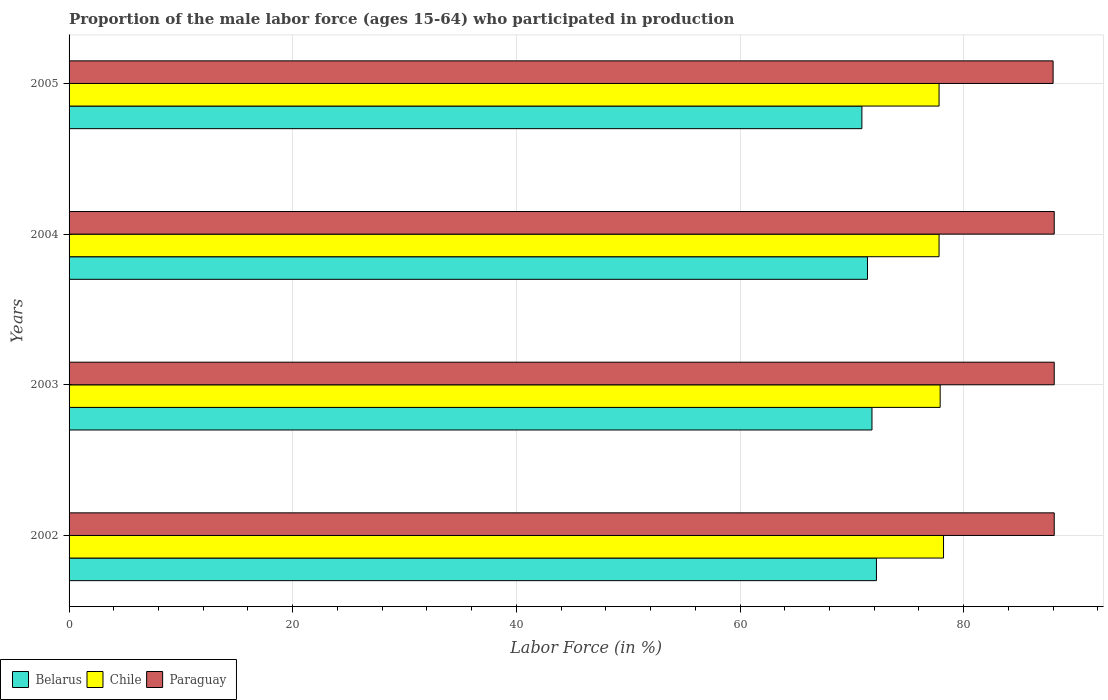How many different coloured bars are there?
Ensure brevity in your answer.  3. Are the number of bars per tick equal to the number of legend labels?
Your answer should be compact. Yes. How many bars are there on the 4th tick from the bottom?
Offer a terse response. 3. What is the label of the 3rd group of bars from the top?
Offer a terse response. 2003. In how many cases, is the number of bars for a given year not equal to the number of legend labels?
Ensure brevity in your answer.  0. What is the proportion of the male labor force who participated in production in Paraguay in 2002?
Make the answer very short. 88.1. Across all years, what is the maximum proportion of the male labor force who participated in production in Belarus?
Ensure brevity in your answer.  72.2. Across all years, what is the minimum proportion of the male labor force who participated in production in Chile?
Keep it short and to the point. 77.8. What is the total proportion of the male labor force who participated in production in Paraguay in the graph?
Keep it short and to the point. 352.3. What is the difference between the proportion of the male labor force who participated in production in Chile in 2003 and that in 2004?
Keep it short and to the point. 0.1. What is the difference between the proportion of the male labor force who participated in production in Belarus in 2004 and the proportion of the male labor force who participated in production in Paraguay in 2003?
Provide a short and direct response. -16.7. What is the average proportion of the male labor force who participated in production in Paraguay per year?
Your answer should be compact. 88.07. In how many years, is the proportion of the male labor force who participated in production in Belarus greater than 68 %?
Your response must be concise. 4. What is the ratio of the proportion of the male labor force who participated in production in Chile in 2002 to that in 2005?
Keep it short and to the point. 1.01. Is the proportion of the male labor force who participated in production in Belarus in 2002 less than that in 2005?
Provide a succinct answer. No. What is the difference between the highest and the second highest proportion of the male labor force who participated in production in Belarus?
Your answer should be compact. 0.4. What is the difference between the highest and the lowest proportion of the male labor force who participated in production in Belarus?
Give a very brief answer. 1.3. In how many years, is the proportion of the male labor force who participated in production in Paraguay greater than the average proportion of the male labor force who participated in production in Paraguay taken over all years?
Offer a very short reply. 3. Is the sum of the proportion of the male labor force who participated in production in Chile in 2002 and 2005 greater than the maximum proportion of the male labor force who participated in production in Paraguay across all years?
Offer a terse response. Yes. What does the 1st bar from the top in 2002 represents?
Make the answer very short. Paraguay. What does the 3rd bar from the bottom in 2002 represents?
Make the answer very short. Paraguay. Are all the bars in the graph horizontal?
Your response must be concise. Yes. How many years are there in the graph?
Give a very brief answer. 4. Are the values on the major ticks of X-axis written in scientific E-notation?
Keep it short and to the point. No. Does the graph contain any zero values?
Provide a succinct answer. No. Does the graph contain grids?
Provide a succinct answer. Yes. How are the legend labels stacked?
Offer a very short reply. Horizontal. What is the title of the graph?
Provide a short and direct response. Proportion of the male labor force (ages 15-64) who participated in production. What is the label or title of the X-axis?
Your answer should be very brief. Labor Force (in %). What is the Labor Force (in %) of Belarus in 2002?
Make the answer very short. 72.2. What is the Labor Force (in %) of Chile in 2002?
Your answer should be very brief. 78.2. What is the Labor Force (in %) of Paraguay in 2002?
Make the answer very short. 88.1. What is the Labor Force (in %) in Belarus in 2003?
Provide a short and direct response. 71.8. What is the Labor Force (in %) in Chile in 2003?
Make the answer very short. 77.9. What is the Labor Force (in %) in Paraguay in 2003?
Your response must be concise. 88.1. What is the Labor Force (in %) of Belarus in 2004?
Offer a very short reply. 71.4. What is the Labor Force (in %) in Chile in 2004?
Keep it short and to the point. 77.8. What is the Labor Force (in %) of Paraguay in 2004?
Give a very brief answer. 88.1. What is the Labor Force (in %) in Belarus in 2005?
Provide a succinct answer. 70.9. What is the Labor Force (in %) of Chile in 2005?
Your answer should be very brief. 77.8. What is the Labor Force (in %) of Paraguay in 2005?
Keep it short and to the point. 88. Across all years, what is the maximum Labor Force (in %) in Belarus?
Make the answer very short. 72.2. Across all years, what is the maximum Labor Force (in %) in Chile?
Your response must be concise. 78.2. Across all years, what is the maximum Labor Force (in %) of Paraguay?
Make the answer very short. 88.1. Across all years, what is the minimum Labor Force (in %) of Belarus?
Your answer should be very brief. 70.9. Across all years, what is the minimum Labor Force (in %) in Chile?
Offer a very short reply. 77.8. What is the total Labor Force (in %) of Belarus in the graph?
Keep it short and to the point. 286.3. What is the total Labor Force (in %) in Chile in the graph?
Keep it short and to the point. 311.7. What is the total Labor Force (in %) in Paraguay in the graph?
Provide a short and direct response. 352.3. What is the difference between the Labor Force (in %) of Belarus in 2002 and that in 2003?
Your response must be concise. 0.4. What is the difference between the Labor Force (in %) of Paraguay in 2002 and that in 2003?
Your answer should be very brief. 0. What is the difference between the Labor Force (in %) in Chile in 2002 and that in 2004?
Offer a terse response. 0.4. What is the difference between the Labor Force (in %) of Paraguay in 2002 and that in 2004?
Your response must be concise. 0. What is the difference between the Labor Force (in %) in Belarus in 2002 and that in 2005?
Your answer should be very brief. 1.3. What is the difference between the Labor Force (in %) of Belarus in 2003 and that in 2004?
Your answer should be very brief. 0.4. What is the difference between the Labor Force (in %) in Paraguay in 2003 and that in 2004?
Keep it short and to the point. 0. What is the difference between the Labor Force (in %) in Belarus in 2003 and that in 2005?
Make the answer very short. 0.9. What is the difference between the Labor Force (in %) in Chile in 2003 and that in 2005?
Keep it short and to the point. 0.1. What is the difference between the Labor Force (in %) in Paraguay in 2003 and that in 2005?
Provide a succinct answer. 0.1. What is the difference between the Labor Force (in %) in Belarus in 2004 and that in 2005?
Offer a very short reply. 0.5. What is the difference between the Labor Force (in %) in Chile in 2004 and that in 2005?
Give a very brief answer. 0. What is the difference between the Labor Force (in %) in Paraguay in 2004 and that in 2005?
Your response must be concise. 0.1. What is the difference between the Labor Force (in %) in Belarus in 2002 and the Labor Force (in %) in Paraguay in 2003?
Your answer should be compact. -15.9. What is the difference between the Labor Force (in %) in Belarus in 2002 and the Labor Force (in %) in Chile in 2004?
Make the answer very short. -5.6. What is the difference between the Labor Force (in %) in Belarus in 2002 and the Labor Force (in %) in Paraguay in 2004?
Keep it short and to the point. -15.9. What is the difference between the Labor Force (in %) of Chile in 2002 and the Labor Force (in %) of Paraguay in 2004?
Your response must be concise. -9.9. What is the difference between the Labor Force (in %) in Belarus in 2002 and the Labor Force (in %) in Chile in 2005?
Keep it short and to the point. -5.6. What is the difference between the Labor Force (in %) in Belarus in 2002 and the Labor Force (in %) in Paraguay in 2005?
Your response must be concise. -15.8. What is the difference between the Labor Force (in %) of Chile in 2002 and the Labor Force (in %) of Paraguay in 2005?
Keep it short and to the point. -9.8. What is the difference between the Labor Force (in %) of Belarus in 2003 and the Labor Force (in %) of Chile in 2004?
Ensure brevity in your answer.  -6. What is the difference between the Labor Force (in %) of Belarus in 2003 and the Labor Force (in %) of Paraguay in 2004?
Provide a succinct answer. -16.3. What is the difference between the Labor Force (in %) of Belarus in 2003 and the Labor Force (in %) of Chile in 2005?
Give a very brief answer. -6. What is the difference between the Labor Force (in %) in Belarus in 2003 and the Labor Force (in %) in Paraguay in 2005?
Offer a terse response. -16.2. What is the difference between the Labor Force (in %) of Chile in 2003 and the Labor Force (in %) of Paraguay in 2005?
Your answer should be very brief. -10.1. What is the difference between the Labor Force (in %) of Belarus in 2004 and the Labor Force (in %) of Chile in 2005?
Offer a very short reply. -6.4. What is the difference between the Labor Force (in %) of Belarus in 2004 and the Labor Force (in %) of Paraguay in 2005?
Provide a succinct answer. -16.6. What is the difference between the Labor Force (in %) in Chile in 2004 and the Labor Force (in %) in Paraguay in 2005?
Offer a terse response. -10.2. What is the average Labor Force (in %) in Belarus per year?
Your response must be concise. 71.58. What is the average Labor Force (in %) in Chile per year?
Ensure brevity in your answer.  77.92. What is the average Labor Force (in %) of Paraguay per year?
Ensure brevity in your answer.  88.08. In the year 2002, what is the difference between the Labor Force (in %) in Belarus and Labor Force (in %) in Paraguay?
Keep it short and to the point. -15.9. In the year 2003, what is the difference between the Labor Force (in %) in Belarus and Labor Force (in %) in Chile?
Keep it short and to the point. -6.1. In the year 2003, what is the difference between the Labor Force (in %) in Belarus and Labor Force (in %) in Paraguay?
Your answer should be very brief. -16.3. In the year 2004, what is the difference between the Labor Force (in %) in Belarus and Labor Force (in %) in Chile?
Offer a very short reply. -6.4. In the year 2004, what is the difference between the Labor Force (in %) in Belarus and Labor Force (in %) in Paraguay?
Your response must be concise. -16.7. In the year 2004, what is the difference between the Labor Force (in %) in Chile and Labor Force (in %) in Paraguay?
Provide a succinct answer. -10.3. In the year 2005, what is the difference between the Labor Force (in %) in Belarus and Labor Force (in %) in Chile?
Make the answer very short. -6.9. In the year 2005, what is the difference between the Labor Force (in %) of Belarus and Labor Force (in %) of Paraguay?
Ensure brevity in your answer.  -17.1. In the year 2005, what is the difference between the Labor Force (in %) in Chile and Labor Force (in %) in Paraguay?
Offer a terse response. -10.2. What is the ratio of the Labor Force (in %) of Belarus in 2002 to that in 2003?
Provide a succinct answer. 1.01. What is the ratio of the Labor Force (in %) of Chile in 2002 to that in 2003?
Make the answer very short. 1. What is the ratio of the Labor Force (in %) in Belarus in 2002 to that in 2004?
Ensure brevity in your answer.  1.01. What is the ratio of the Labor Force (in %) of Chile in 2002 to that in 2004?
Provide a succinct answer. 1.01. What is the ratio of the Labor Force (in %) in Belarus in 2002 to that in 2005?
Make the answer very short. 1.02. What is the ratio of the Labor Force (in %) of Chile in 2002 to that in 2005?
Give a very brief answer. 1.01. What is the ratio of the Labor Force (in %) of Paraguay in 2002 to that in 2005?
Ensure brevity in your answer.  1. What is the ratio of the Labor Force (in %) of Belarus in 2003 to that in 2004?
Your response must be concise. 1.01. What is the ratio of the Labor Force (in %) in Chile in 2003 to that in 2004?
Your answer should be compact. 1. What is the ratio of the Labor Force (in %) in Belarus in 2003 to that in 2005?
Your answer should be very brief. 1.01. What is the ratio of the Labor Force (in %) in Paraguay in 2003 to that in 2005?
Your response must be concise. 1. What is the ratio of the Labor Force (in %) in Belarus in 2004 to that in 2005?
Your answer should be compact. 1.01. What is the ratio of the Labor Force (in %) of Chile in 2004 to that in 2005?
Ensure brevity in your answer.  1. What is the difference between the highest and the second highest Labor Force (in %) of Belarus?
Offer a very short reply. 0.4. What is the difference between the highest and the second highest Labor Force (in %) in Chile?
Provide a succinct answer. 0.3. What is the difference between the highest and the lowest Labor Force (in %) of Chile?
Offer a terse response. 0.4. What is the difference between the highest and the lowest Labor Force (in %) of Paraguay?
Offer a very short reply. 0.1. 